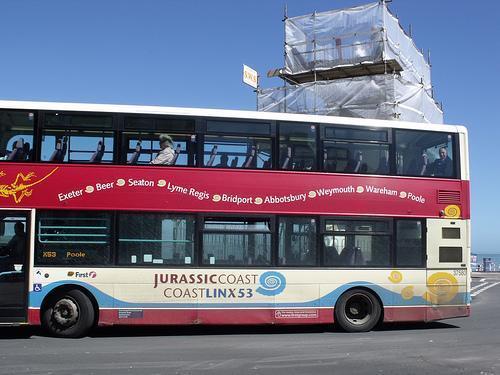How many buses are pictured?
Give a very brief answer. 1. How many levels are on the bus?
Give a very brief answer. 2. How many people can be seen on the top level?
Give a very brief answer. 2. How many wheels are visible?
Give a very brief answer. 2. How many doors can be seen on the bus?
Give a very brief answer. 1. 